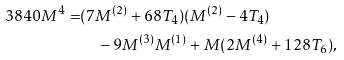<formula> <loc_0><loc_0><loc_500><loc_500>3 8 4 0 M ^ { 4 } = & ( 7 M ^ { ( 2 ) } + 6 8 T _ { 4 } ) ( M ^ { ( 2 ) } - 4 T _ { 4 } ) \\ & \quad - 9 M ^ { ( 3 ) } M ^ { ( 1 ) } + M ( 2 M ^ { ( 4 ) } + 1 2 8 T _ { 6 } ) ,</formula> 